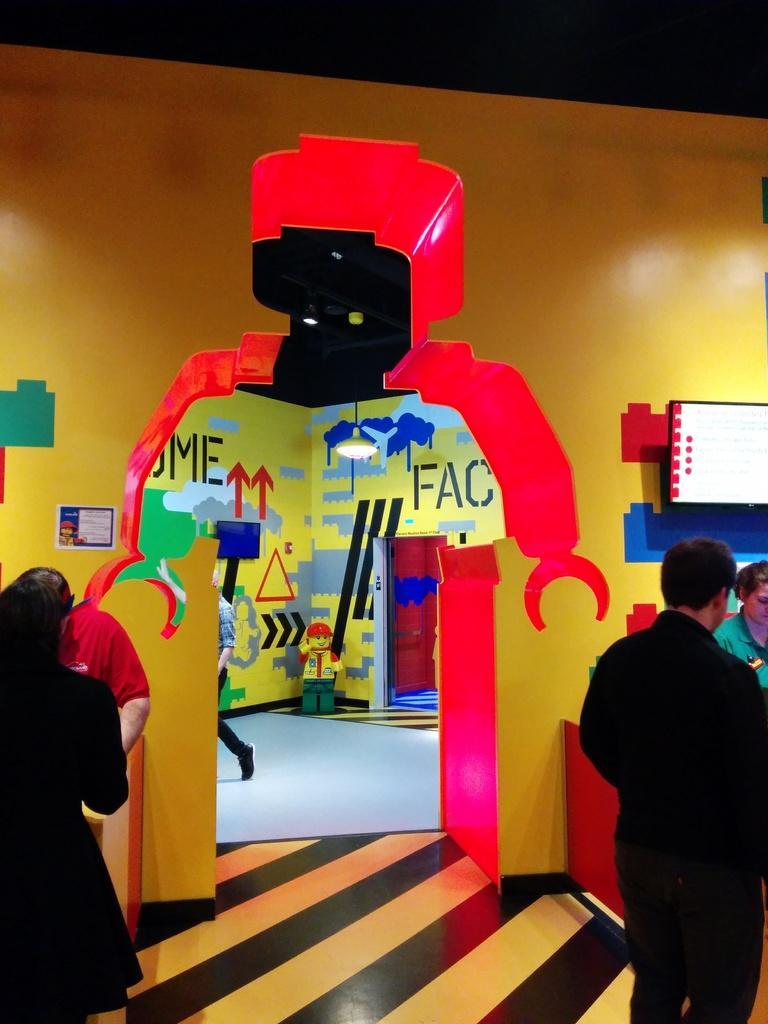Could you give a brief overview of what you see in this image? In the picture we can see a floor with black and yellow lines on the either side of the floor, we can see some people are standing and in the wall we can see it is shaped in the kind of a person and from it we can see another room with a color full wall and a doll near the wall and a person walking out. 